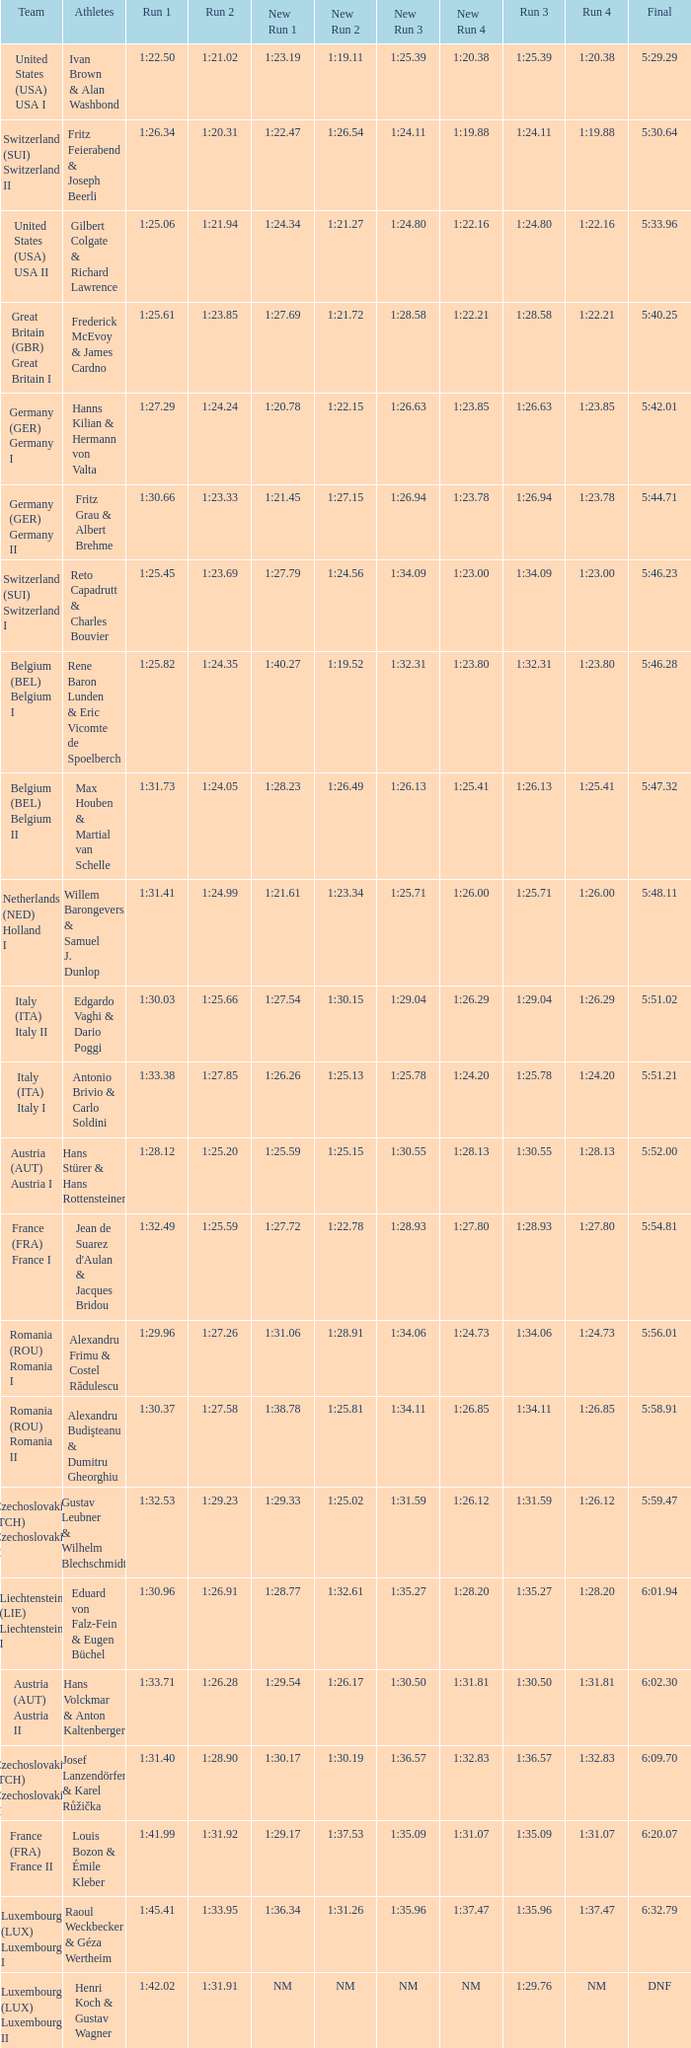Which Run 4 has Athletes of alexandru frimu & costel rădulescu? 1:24.73. 